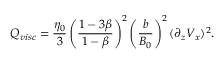Convert formula to latex. <formula><loc_0><loc_0><loc_500><loc_500>Q _ { v i s c } = \frac { \eta _ { 0 } } { 3 } \left ( \frac { 1 - 3 \beta } { 1 - \beta } \right ) ^ { 2 } \left ( \frac { b } { B _ { 0 } } \right ) ^ { 2 } ( \partial _ { z } V _ { x } ) ^ { 2 } .</formula> 